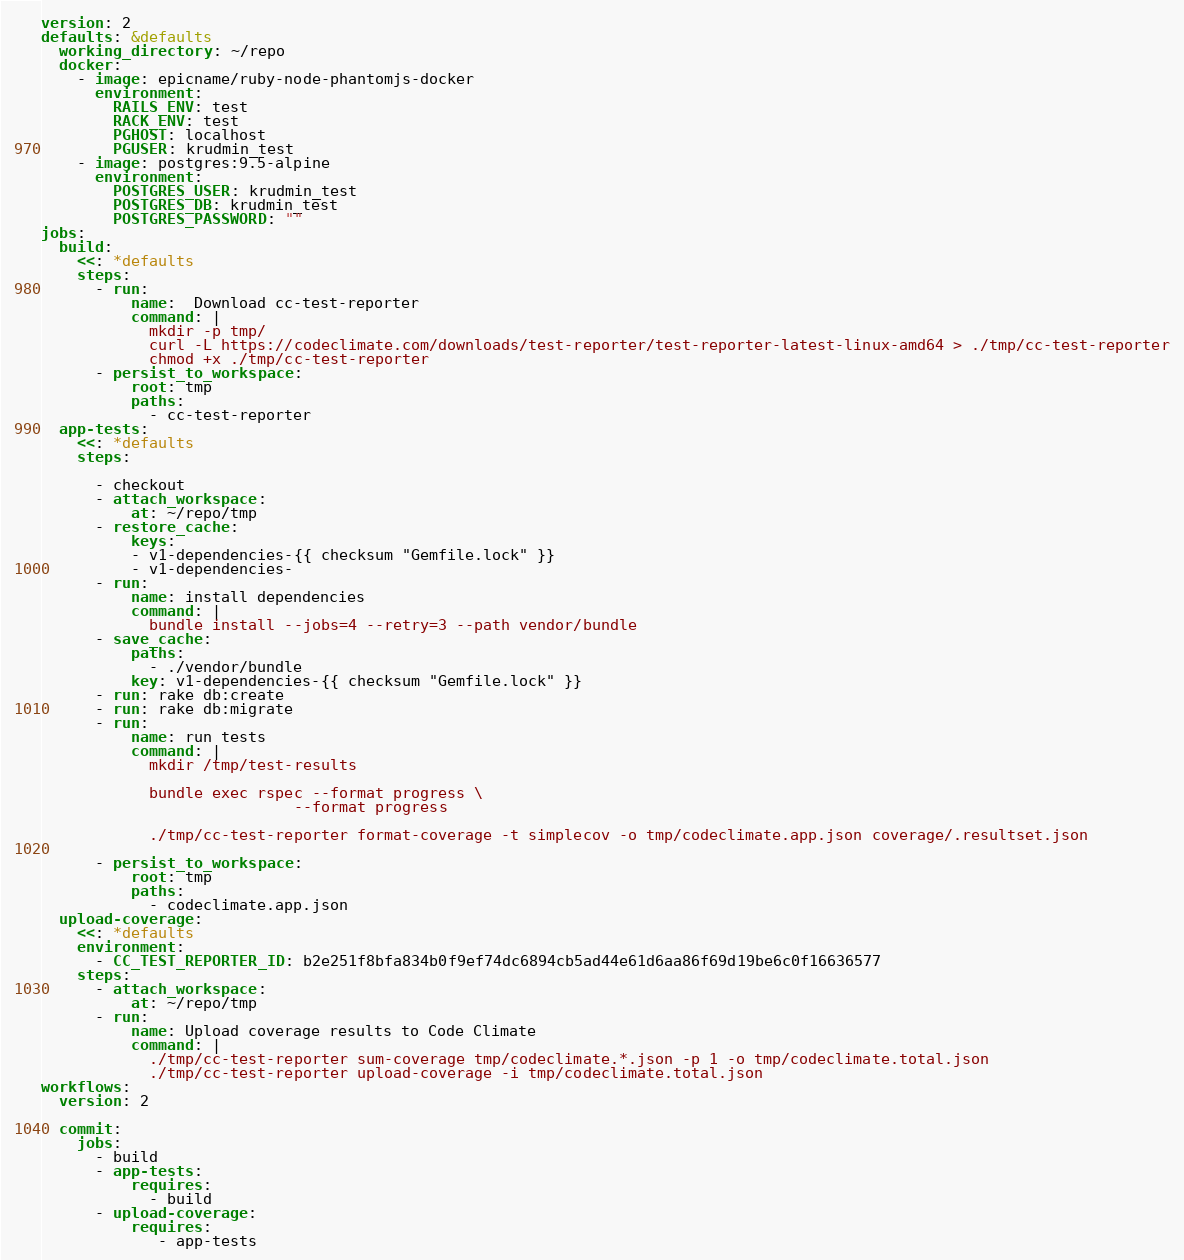Convert code to text. <code><loc_0><loc_0><loc_500><loc_500><_YAML_>version: 2
defaults: &defaults
  working_directory: ~/repo
  docker:
    - image: epicname/ruby-node-phantomjs-docker
      environment:
        RAILS_ENV: test
        RACK_ENV: test
        PGHOST: localhost
        PGUSER: krudmin_test
    - image: postgres:9.5-alpine
      environment:
        POSTGRES_USER: krudmin_test
        POSTGRES_DB: krudmin_test
        POSTGRES_PASSWORD: ""
jobs:
  build:
    <<: *defaults
    steps:
      - run:
          name:  Download cc-test-reporter
          command: |
            mkdir -p tmp/
            curl -L https://codeclimate.com/downloads/test-reporter/test-reporter-latest-linux-amd64 > ./tmp/cc-test-reporter
            chmod +x ./tmp/cc-test-reporter
      - persist_to_workspace:
          root: tmp
          paths:
            - cc-test-reporter
  app-tests:
    <<: *defaults
    steps:

      - checkout
      - attach_workspace:
          at: ~/repo/tmp
      - restore_cache:
          keys:
          - v1-dependencies-{{ checksum "Gemfile.lock" }}
          - v1-dependencies-
      - run:
          name: install dependencies
          command: |
            bundle install --jobs=4 --retry=3 --path vendor/bundle
      - save_cache:
          paths:
            - ./vendor/bundle
          key: v1-dependencies-{{ checksum "Gemfile.lock" }}
      - run: rake db:create
      - run: rake db:migrate
      - run:
          name: run tests
          command: |
            mkdir /tmp/test-results

            bundle exec rspec --format progress \
                            --format progress

            ./tmp/cc-test-reporter format-coverage -t simplecov -o tmp/codeclimate.app.json coverage/.resultset.json

      - persist_to_workspace:
          root: tmp
          paths:
            - codeclimate.app.json
  upload-coverage:
    <<: *defaults
    environment:
      - CC_TEST_REPORTER_ID: b2e251f8bfa834b0f9ef74dc6894cb5ad44e61d6aa86f69d19be6c0f16636577
    steps:
      - attach_workspace:
          at: ~/repo/tmp
      - run:
          name: Upload coverage results to Code Climate
          command: |
            ./tmp/cc-test-reporter sum-coverage tmp/codeclimate.*.json -p 1 -o tmp/codeclimate.total.json
            ./tmp/cc-test-reporter upload-coverage -i tmp/codeclimate.total.json
workflows:
  version: 2

  commit:
    jobs:
      - build
      - app-tests:
          requires:
            - build
      - upload-coverage:
          requires:
             - app-tests
</code> 